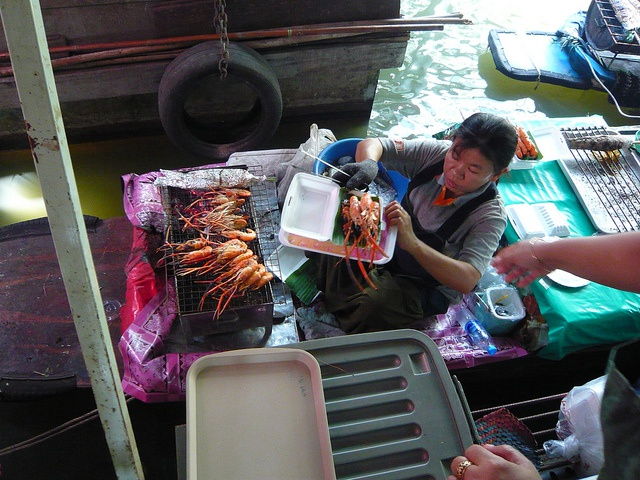Describe the objects in this image and their specific colors. I can see boat in gray, black, white, and maroon tones, people in gray, black, maroon, and darkgray tones, boat in gray, white, black, navy, and blue tones, and people in gray, brown, maroon, and darkgray tones in this image. 